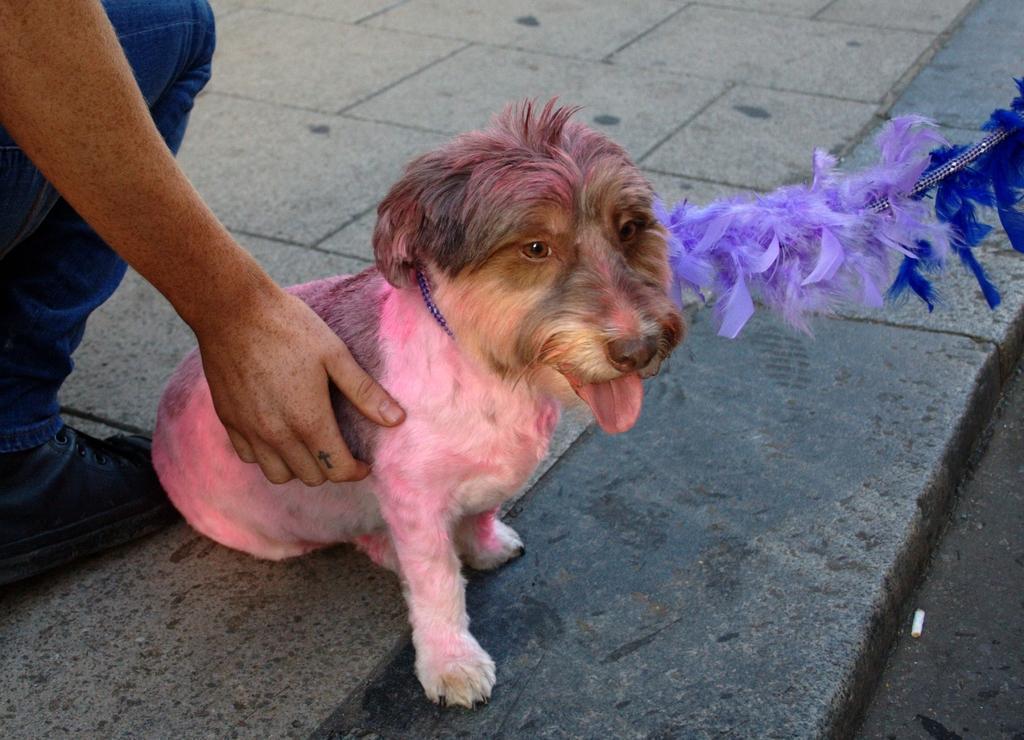How would you summarize this image in a sentence or two? On the left side, there is a person placing hand on the dog which is sitting and is having a belt which is connected to a thread. And they are on the floor. 